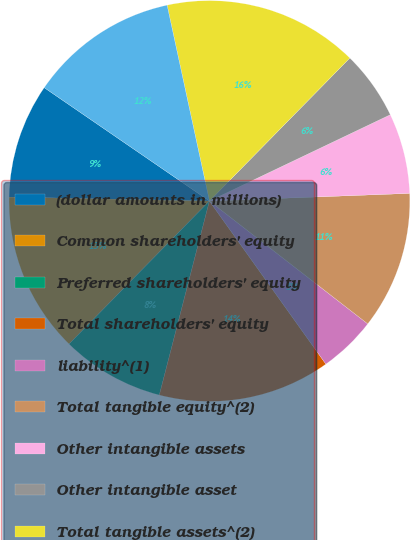Convert chart to OTSL. <chart><loc_0><loc_0><loc_500><loc_500><pie_chart><fcel>(dollar amounts in millions)<fcel>Common shareholders' equity<fcel>Preferred shareholders' equity<fcel>Total shareholders' equity<fcel>liability^(1)<fcel>Total tangible equity^(2)<fcel>Other intangible assets<fcel>Other intangible asset<fcel>Total tangible assets^(2)<fcel>Tier 1 capital<nl><fcel>9.26%<fcel>12.96%<fcel>8.33%<fcel>13.89%<fcel>4.63%<fcel>11.11%<fcel>6.48%<fcel>5.56%<fcel>15.74%<fcel>12.04%<nl></chart> 